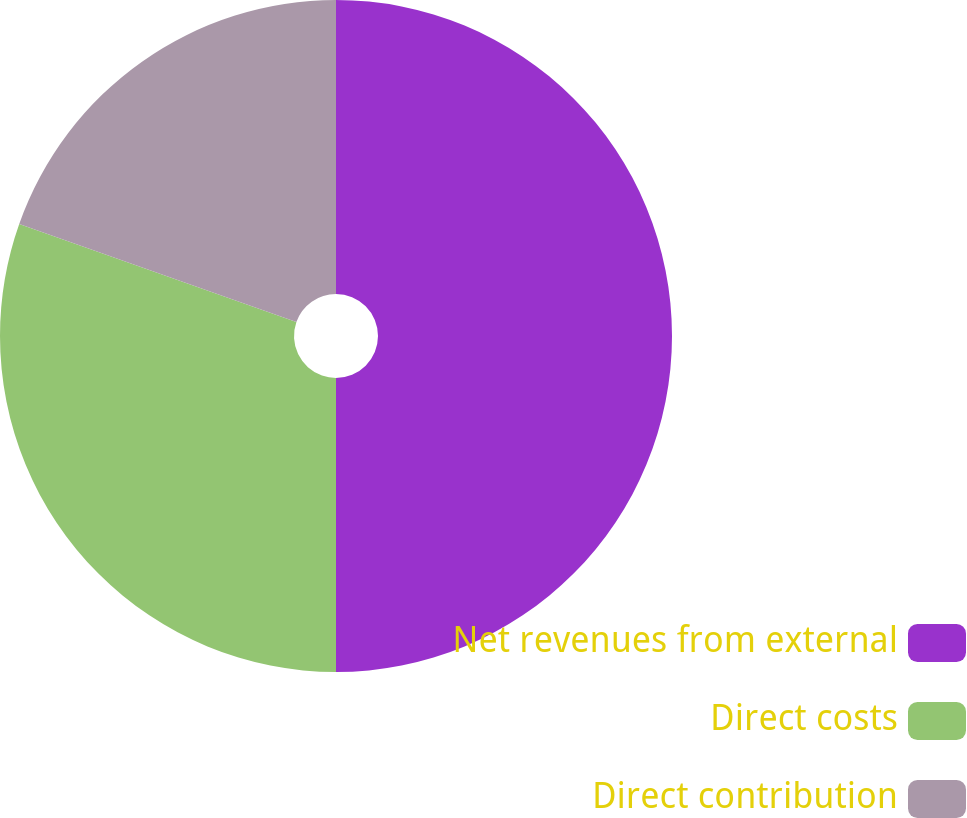Convert chart. <chart><loc_0><loc_0><loc_500><loc_500><pie_chart><fcel>Net revenues from external<fcel>Direct costs<fcel>Direct contribution<nl><fcel>50.0%<fcel>30.41%<fcel>19.59%<nl></chart> 